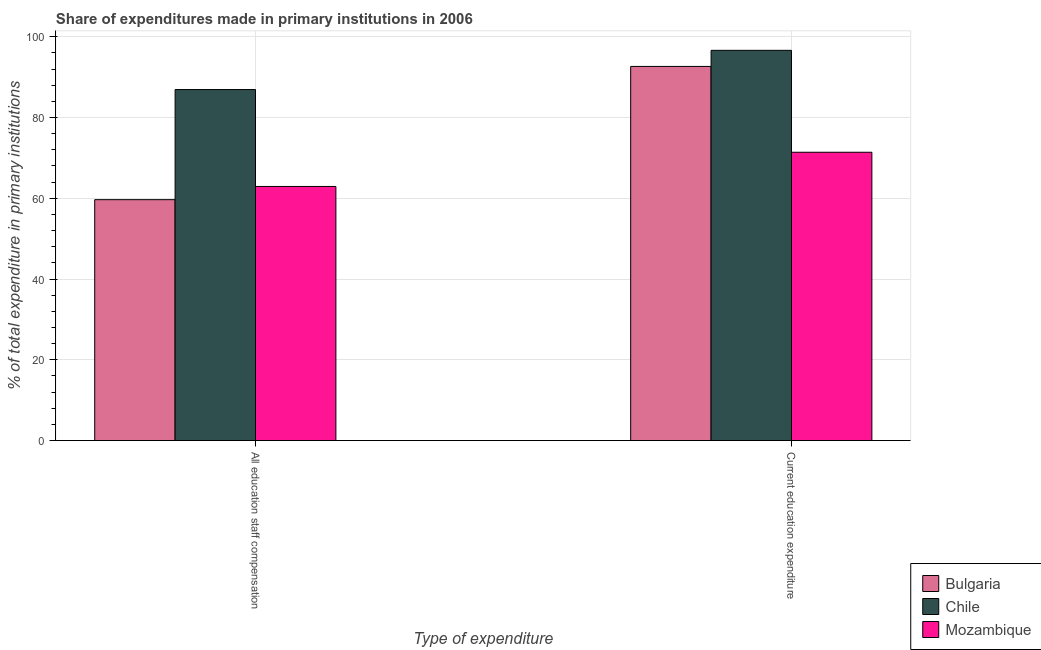How many groups of bars are there?
Ensure brevity in your answer.  2. Are the number of bars on each tick of the X-axis equal?
Keep it short and to the point. Yes. How many bars are there on the 1st tick from the left?
Provide a short and direct response. 3. How many bars are there on the 2nd tick from the right?
Keep it short and to the point. 3. What is the label of the 2nd group of bars from the left?
Ensure brevity in your answer.  Current education expenditure. What is the expenditure in staff compensation in Bulgaria?
Ensure brevity in your answer.  59.65. Across all countries, what is the maximum expenditure in staff compensation?
Provide a short and direct response. 86.92. Across all countries, what is the minimum expenditure in education?
Make the answer very short. 71.39. What is the total expenditure in staff compensation in the graph?
Provide a succinct answer. 209.49. What is the difference between the expenditure in education in Chile and that in Mozambique?
Offer a terse response. 25.24. What is the difference between the expenditure in education in Mozambique and the expenditure in staff compensation in Chile?
Keep it short and to the point. -15.52. What is the average expenditure in staff compensation per country?
Make the answer very short. 69.83. What is the difference between the expenditure in education and expenditure in staff compensation in Mozambique?
Your response must be concise. 8.47. What is the ratio of the expenditure in education in Chile to that in Bulgaria?
Make the answer very short. 1.04. Is the expenditure in staff compensation in Bulgaria less than that in Mozambique?
Your response must be concise. Yes. In how many countries, is the expenditure in staff compensation greater than the average expenditure in staff compensation taken over all countries?
Provide a short and direct response. 1. What does the 3rd bar from the left in All education staff compensation represents?
Your response must be concise. Mozambique. What does the 1st bar from the right in Current education expenditure represents?
Your answer should be compact. Mozambique. Are all the bars in the graph horizontal?
Your answer should be compact. No. Does the graph contain grids?
Offer a terse response. Yes. How many legend labels are there?
Offer a terse response. 3. How are the legend labels stacked?
Offer a terse response. Vertical. What is the title of the graph?
Keep it short and to the point. Share of expenditures made in primary institutions in 2006. Does "Suriname" appear as one of the legend labels in the graph?
Your answer should be compact. No. What is the label or title of the X-axis?
Ensure brevity in your answer.  Type of expenditure. What is the label or title of the Y-axis?
Your response must be concise. % of total expenditure in primary institutions. What is the % of total expenditure in primary institutions in Bulgaria in All education staff compensation?
Your response must be concise. 59.65. What is the % of total expenditure in primary institutions of Chile in All education staff compensation?
Keep it short and to the point. 86.92. What is the % of total expenditure in primary institutions of Mozambique in All education staff compensation?
Give a very brief answer. 62.92. What is the % of total expenditure in primary institutions in Bulgaria in Current education expenditure?
Make the answer very short. 92.64. What is the % of total expenditure in primary institutions in Chile in Current education expenditure?
Give a very brief answer. 96.63. What is the % of total expenditure in primary institutions in Mozambique in Current education expenditure?
Your answer should be compact. 71.39. Across all Type of expenditure, what is the maximum % of total expenditure in primary institutions in Bulgaria?
Provide a succinct answer. 92.64. Across all Type of expenditure, what is the maximum % of total expenditure in primary institutions of Chile?
Make the answer very short. 96.63. Across all Type of expenditure, what is the maximum % of total expenditure in primary institutions of Mozambique?
Offer a very short reply. 71.39. Across all Type of expenditure, what is the minimum % of total expenditure in primary institutions of Bulgaria?
Your answer should be compact. 59.65. Across all Type of expenditure, what is the minimum % of total expenditure in primary institutions in Chile?
Give a very brief answer. 86.92. Across all Type of expenditure, what is the minimum % of total expenditure in primary institutions of Mozambique?
Keep it short and to the point. 62.92. What is the total % of total expenditure in primary institutions of Bulgaria in the graph?
Provide a succinct answer. 152.29. What is the total % of total expenditure in primary institutions in Chile in the graph?
Provide a short and direct response. 183.55. What is the total % of total expenditure in primary institutions of Mozambique in the graph?
Your answer should be very brief. 134.31. What is the difference between the % of total expenditure in primary institutions in Bulgaria in All education staff compensation and that in Current education expenditure?
Your response must be concise. -32.99. What is the difference between the % of total expenditure in primary institutions of Chile in All education staff compensation and that in Current education expenditure?
Provide a short and direct response. -9.71. What is the difference between the % of total expenditure in primary institutions in Mozambique in All education staff compensation and that in Current education expenditure?
Make the answer very short. -8.47. What is the difference between the % of total expenditure in primary institutions of Bulgaria in All education staff compensation and the % of total expenditure in primary institutions of Chile in Current education expenditure?
Give a very brief answer. -36.98. What is the difference between the % of total expenditure in primary institutions in Bulgaria in All education staff compensation and the % of total expenditure in primary institutions in Mozambique in Current education expenditure?
Your answer should be compact. -11.74. What is the difference between the % of total expenditure in primary institutions of Chile in All education staff compensation and the % of total expenditure in primary institutions of Mozambique in Current education expenditure?
Keep it short and to the point. 15.52. What is the average % of total expenditure in primary institutions of Bulgaria per Type of expenditure?
Provide a short and direct response. 76.15. What is the average % of total expenditure in primary institutions of Chile per Type of expenditure?
Give a very brief answer. 91.77. What is the average % of total expenditure in primary institutions of Mozambique per Type of expenditure?
Give a very brief answer. 67.16. What is the difference between the % of total expenditure in primary institutions of Bulgaria and % of total expenditure in primary institutions of Chile in All education staff compensation?
Ensure brevity in your answer.  -27.26. What is the difference between the % of total expenditure in primary institutions of Bulgaria and % of total expenditure in primary institutions of Mozambique in All education staff compensation?
Your answer should be compact. -3.27. What is the difference between the % of total expenditure in primary institutions of Chile and % of total expenditure in primary institutions of Mozambique in All education staff compensation?
Your response must be concise. 23.99. What is the difference between the % of total expenditure in primary institutions in Bulgaria and % of total expenditure in primary institutions in Chile in Current education expenditure?
Offer a very short reply. -3.99. What is the difference between the % of total expenditure in primary institutions in Bulgaria and % of total expenditure in primary institutions in Mozambique in Current education expenditure?
Provide a succinct answer. 21.25. What is the difference between the % of total expenditure in primary institutions of Chile and % of total expenditure in primary institutions of Mozambique in Current education expenditure?
Keep it short and to the point. 25.24. What is the ratio of the % of total expenditure in primary institutions of Bulgaria in All education staff compensation to that in Current education expenditure?
Provide a succinct answer. 0.64. What is the ratio of the % of total expenditure in primary institutions of Chile in All education staff compensation to that in Current education expenditure?
Your answer should be very brief. 0.9. What is the ratio of the % of total expenditure in primary institutions in Mozambique in All education staff compensation to that in Current education expenditure?
Your response must be concise. 0.88. What is the difference between the highest and the second highest % of total expenditure in primary institutions in Bulgaria?
Your response must be concise. 32.99. What is the difference between the highest and the second highest % of total expenditure in primary institutions in Chile?
Keep it short and to the point. 9.71. What is the difference between the highest and the second highest % of total expenditure in primary institutions of Mozambique?
Offer a terse response. 8.47. What is the difference between the highest and the lowest % of total expenditure in primary institutions in Bulgaria?
Provide a short and direct response. 32.99. What is the difference between the highest and the lowest % of total expenditure in primary institutions in Chile?
Make the answer very short. 9.71. What is the difference between the highest and the lowest % of total expenditure in primary institutions in Mozambique?
Offer a very short reply. 8.47. 